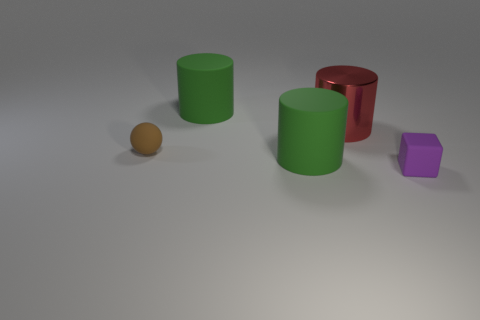Is there any other thing that has the same material as the red cylinder?
Provide a succinct answer. No. Are there any other things that have the same shape as the small purple thing?
Give a very brief answer. No. Is the purple block made of the same material as the green cylinder behind the shiny cylinder?
Offer a terse response. Yes. What material is the object that is in front of the green matte thing in front of the metallic cylinder made of?
Make the answer very short. Rubber. Is the number of small matte cubes that are left of the brown matte ball greater than the number of big objects?
Provide a succinct answer. No. Are there any big green things?
Your answer should be compact. Yes. What color is the tiny rubber object in front of the brown thing?
Provide a short and direct response. Purple. There is a block that is the same size as the brown ball; what is it made of?
Give a very brief answer. Rubber. How many other things are there of the same material as the sphere?
Provide a short and direct response. 3. There is a rubber thing that is both in front of the tiny brown matte ball and on the left side of the purple object; what is its color?
Ensure brevity in your answer.  Green. 